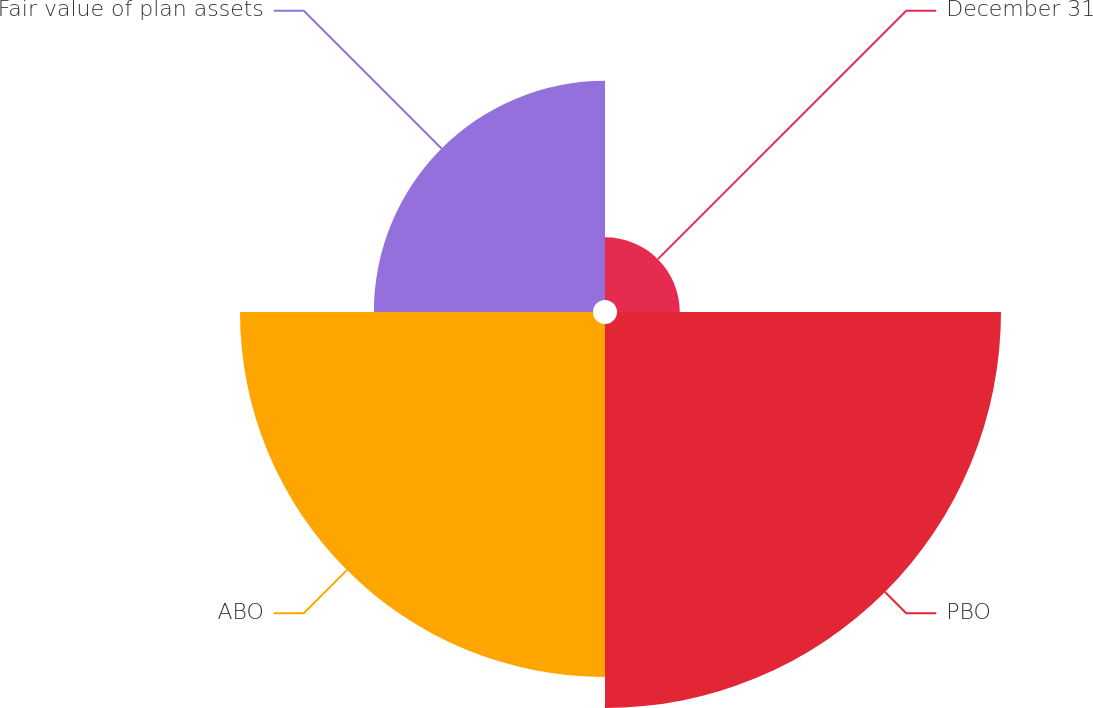<chart> <loc_0><loc_0><loc_500><loc_500><pie_chart><fcel>December 31<fcel>PBO<fcel>ABO<fcel>Fair value of plan assets<nl><fcel>6.16%<fcel>37.69%<fcel>34.65%<fcel>21.51%<nl></chart> 